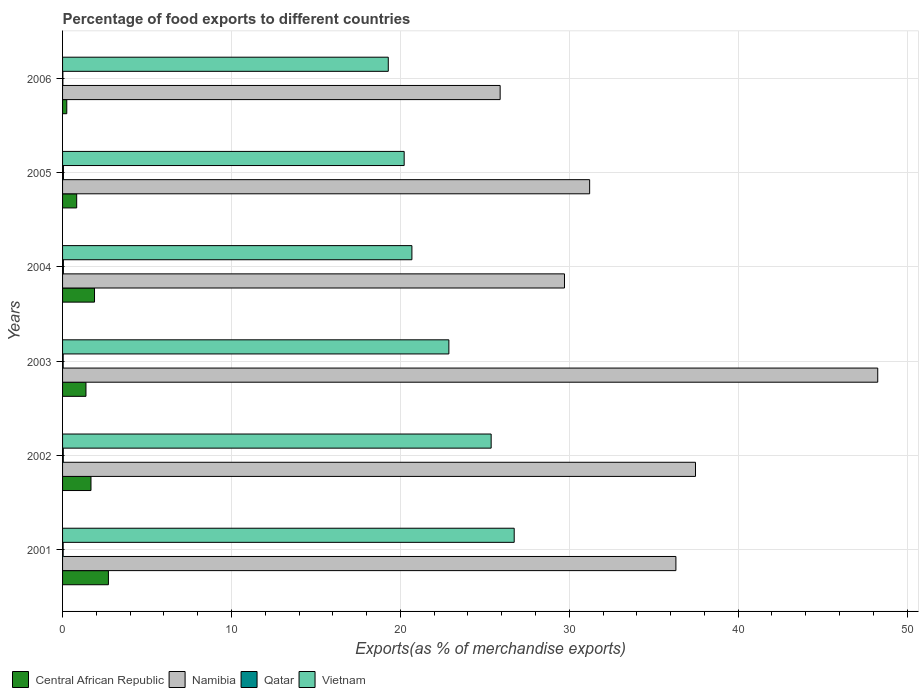How many groups of bars are there?
Offer a terse response. 6. Are the number of bars on each tick of the Y-axis equal?
Offer a terse response. Yes. What is the percentage of exports to different countries in Central African Republic in 2002?
Your answer should be very brief. 1.68. Across all years, what is the maximum percentage of exports to different countries in Qatar?
Your response must be concise. 0.05. Across all years, what is the minimum percentage of exports to different countries in Vietnam?
Ensure brevity in your answer.  19.29. In which year was the percentage of exports to different countries in Central African Republic maximum?
Your answer should be compact. 2001. What is the total percentage of exports to different countries in Namibia in the graph?
Ensure brevity in your answer.  208.9. What is the difference between the percentage of exports to different countries in Qatar in 2001 and that in 2003?
Ensure brevity in your answer.  -0. What is the difference between the percentage of exports to different countries in Central African Republic in 2004 and the percentage of exports to different countries in Qatar in 2002?
Your response must be concise. 1.85. What is the average percentage of exports to different countries in Namibia per year?
Keep it short and to the point. 34.82. In the year 2005, what is the difference between the percentage of exports to different countries in Qatar and percentage of exports to different countries in Namibia?
Provide a succinct answer. -31.16. In how many years, is the percentage of exports to different countries in Namibia greater than 24 %?
Offer a very short reply. 6. What is the ratio of the percentage of exports to different countries in Namibia in 2004 to that in 2005?
Ensure brevity in your answer.  0.95. Is the percentage of exports to different countries in Namibia in 2001 less than that in 2004?
Provide a short and direct response. No. What is the difference between the highest and the second highest percentage of exports to different countries in Namibia?
Your answer should be compact. 10.79. What is the difference between the highest and the lowest percentage of exports to different countries in Namibia?
Your response must be concise. 22.36. What does the 3rd bar from the top in 2001 represents?
Provide a succinct answer. Namibia. What does the 1st bar from the bottom in 2003 represents?
Offer a terse response. Central African Republic. Is it the case that in every year, the sum of the percentage of exports to different countries in Vietnam and percentage of exports to different countries in Namibia is greater than the percentage of exports to different countries in Qatar?
Keep it short and to the point. Yes. Are the values on the major ticks of X-axis written in scientific E-notation?
Provide a short and direct response. No. Does the graph contain any zero values?
Keep it short and to the point. No. Where does the legend appear in the graph?
Offer a terse response. Bottom left. What is the title of the graph?
Offer a terse response. Percentage of food exports to different countries. What is the label or title of the X-axis?
Offer a terse response. Exports(as % of merchandise exports). What is the Exports(as % of merchandise exports) of Central African Republic in 2001?
Your response must be concise. 2.71. What is the Exports(as % of merchandise exports) in Namibia in 2001?
Give a very brief answer. 36.32. What is the Exports(as % of merchandise exports) of Qatar in 2001?
Offer a terse response. 0.04. What is the Exports(as % of merchandise exports) in Vietnam in 2001?
Your response must be concise. 26.74. What is the Exports(as % of merchandise exports) in Central African Republic in 2002?
Give a very brief answer. 1.68. What is the Exports(as % of merchandise exports) in Namibia in 2002?
Offer a terse response. 37.48. What is the Exports(as % of merchandise exports) in Qatar in 2002?
Your answer should be compact. 0.04. What is the Exports(as % of merchandise exports) in Vietnam in 2002?
Ensure brevity in your answer.  25.38. What is the Exports(as % of merchandise exports) in Central African Republic in 2003?
Ensure brevity in your answer.  1.39. What is the Exports(as % of merchandise exports) of Namibia in 2003?
Provide a short and direct response. 48.27. What is the Exports(as % of merchandise exports) of Qatar in 2003?
Your answer should be very brief. 0.04. What is the Exports(as % of merchandise exports) in Vietnam in 2003?
Ensure brevity in your answer.  22.87. What is the Exports(as % of merchandise exports) in Central African Republic in 2004?
Keep it short and to the point. 1.89. What is the Exports(as % of merchandise exports) of Namibia in 2004?
Make the answer very short. 29.72. What is the Exports(as % of merchandise exports) of Qatar in 2004?
Provide a succinct answer. 0.05. What is the Exports(as % of merchandise exports) of Vietnam in 2004?
Provide a short and direct response. 20.69. What is the Exports(as % of merchandise exports) in Central African Republic in 2005?
Offer a terse response. 0.84. What is the Exports(as % of merchandise exports) in Namibia in 2005?
Make the answer very short. 31.21. What is the Exports(as % of merchandise exports) of Qatar in 2005?
Your answer should be very brief. 0.05. What is the Exports(as % of merchandise exports) of Vietnam in 2005?
Give a very brief answer. 20.23. What is the Exports(as % of merchandise exports) in Central African Republic in 2006?
Offer a very short reply. 0.25. What is the Exports(as % of merchandise exports) of Namibia in 2006?
Keep it short and to the point. 25.91. What is the Exports(as % of merchandise exports) of Qatar in 2006?
Keep it short and to the point. 0.02. What is the Exports(as % of merchandise exports) in Vietnam in 2006?
Offer a terse response. 19.29. Across all years, what is the maximum Exports(as % of merchandise exports) in Central African Republic?
Your answer should be compact. 2.71. Across all years, what is the maximum Exports(as % of merchandise exports) of Namibia?
Offer a terse response. 48.27. Across all years, what is the maximum Exports(as % of merchandise exports) in Qatar?
Give a very brief answer. 0.05. Across all years, what is the maximum Exports(as % of merchandise exports) in Vietnam?
Provide a short and direct response. 26.74. Across all years, what is the minimum Exports(as % of merchandise exports) of Central African Republic?
Provide a short and direct response. 0.25. Across all years, what is the minimum Exports(as % of merchandise exports) in Namibia?
Give a very brief answer. 25.91. Across all years, what is the minimum Exports(as % of merchandise exports) in Qatar?
Give a very brief answer. 0.02. Across all years, what is the minimum Exports(as % of merchandise exports) in Vietnam?
Keep it short and to the point. 19.29. What is the total Exports(as % of merchandise exports) in Central African Republic in the graph?
Make the answer very short. 8.76. What is the total Exports(as % of merchandise exports) in Namibia in the graph?
Offer a very short reply. 208.9. What is the total Exports(as % of merchandise exports) in Qatar in the graph?
Offer a very short reply. 0.23. What is the total Exports(as % of merchandise exports) of Vietnam in the graph?
Ensure brevity in your answer.  135.19. What is the difference between the Exports(as % of merchandise exports) in Central African Republic in 2001 and that in 2002?
Ensure brevity in your answer.  1.03. What is the difference between the Exports(as % of merchandise exports) in Namibia in 2001 and that in 2002?
Offer a very short reply. -1.16. What is the difference between the Exports(as % of merchandise exports) of Qatar in 2001 and that in 2002?
Give a very brief answer. -0.01. What is the difference between the Exports(as % of merchandise exports) in Vietnam in 2001 and that in 2002?
Your answer should be compact. 1.36. What is the difference between the Exports(as % of merchandise exports) of Central African Republic in 2001 and that in 2003?
Offer a terse response. 1.33. What is the difference between the Exports(as % of merchandise exports) in Namibia in 2001 and that in 2003?
Ensure brevity in your answer.  -11.95. What is the difference between the Exports(as % of merchandise exports) of Qatar in 2001 and that in 2003?
Make the answer very short. -0. What is the difference between the Exports(as % of merchandise exports) of Vietnam in 2001 and that in 2003?
Ensure brevity in your answer.  3.87. What is the difference between the Exports(as % of merchandise exports) of Central African Republic in 2001 and that in 2004?
Offer a terse response. 0.82. What is the difference between the Exports(as % of merchandise exports) in Namibia in 2001 and that in 2004?
Your answer should be very brief. 6.6. What is the difference between the Exports(as % of merchandise exports) in Qatar in 2001 and that in 2004?
Keep it short and to the point. -0.01. What is the difference between the Exports(as % of merchandise exports) in Vietnam in 2001 and that in 2004?
Your answer should be very brief. 6.06. What is the difference between the Exports(as % of merchandise exports) of Central African Republic in 2001 and that in 2005?
Provide a short and direct response. 1.88. What is the difference between the Exports(as % of merchandise exports) of Namibia in 2001 and that in 2005?
Your answer should be compact. 5.11. What is the difference between the Exports(as % of merchandise exports) in Qatar in 2001 and that in 2005?
Make the answer very short. -0.02. What is the difference between the Exports(as % of merchandise exports) of Vietnam in 2001 and that in 2005?
Give a very brief answer. 6.51. What is the difference between the Exports(as % of merchandise exports) in Central African Republic in 2001 and that in 2006?
Your answer should be compact. 2.46. What is the difference between the Exports(as % of merchandise exports) of Namibia in 2001 and that in 2006?
Keep it short and to the point. 10.41. What is the difference between the Exports(as % of merchandise exports) in Qatar in 2001 and that in 2006?
Offer a very short reply. 0.02. What is the difference between the Exports(as % of merchandise exports) of Vietnam in 2001 and that in 2006?
Your response must be concise. 7.46. What is the difference between the Exports(as % of merchandise exports) in Central African Republic in 2002 and that in 2003?
Make the answer very short. 0.3. What is the difference between the Exports(as % of merchandise exports) in Namibia in 2002 and that in 2003?
Your response must be concise. -10.79. What is the difference between the Exports(as % of merchandise exports) in Qatar in 2002 and that in 2003?
Give a very brief answer. 0.01. What is the difference between the Exports(as % of merchandise exports) in Vietnam in 2002 and that in 2003?
Make the answer very short. 2.5. What is the difference between the Exports(as % of merchandise exports) of Central African Republic in 2002 and that in 2004?
Keep it short and to the point. -0.21. What is the difference between the Exports(as % of merchandise exports) of Namibia in 2002 and that in 2004?
Your answer should be compact. 7.76. What is the difference between the Exports(as % of merchandise exports) of Qatar in 2002 and that in 2004?
Make the answer very short. -0.01. What is the difference between the Exports(as % of merchandise exports) in Vietnam in 2002 and that in 2004?
Offer a very short reply. 4.69. What is the difference between the Exports(as % of merchandise exports) in Central African Republic in 2002 and that in 2005?
Keep it short and to the point. 0.85. What is the difference between the Exports(as % of merchandise exports) in Namibia in 2002 and that in 2005?
Ensure brevity in your answer.  6.27. What is the difference between the Exports(as % of merchandise exports) of Qatar in 2002 and that in 2005?
Ensure brevity in your answer.  -0.01. What is the difference between the Exports(as % of merchandise exports) of Vietnam in 2002 and that in 2005?
Provide a short and direct response. 5.15. What is the difference between the Exports(as % of merchandise exports) in Central African Republic in 2002 and that in 2006?
Your answer should be compact. 1.43. What is the difference between the Exports(as % of merchandise exports) of Namibia in 2002 and that in 2006?
Your response must be concise. 11.57. What is the difference between the Exports(as % of merchandise exports) in Qatar in 2002 and that in 2006?
Offer a terse response. 0.02. What is the difference between the Exports(as % of merchandise exports) in Vietnam in 2002 and that in 2006?
Ensure brevity in your answer.  6.09. What is the difference between the Exports(as % of merchandise exports) in Central African Republic in 2003 and that in 2004?
Your answer should be very brief. -0.51. What is the difference between the Exports(as % of merchandise exports) in Namibia in 2003 and that in 2004?
Provide a short and direct response. 18.55. What is the difference between the Exports(as % of merchandise exports) in Qatar in 2003 and that in 2004?
Ensure brevity in your answer.  -0.01. What is the difference between the Exports(as % of merchandise exports) in Vietnam in 2003 and that in 2004?
Your answer should be compact. 2.19. What is the difference between the Exports(as % of merchandise exports) of Central African Republic in 2003 and that in 2005?
Offer a terse response. 0.55. What is the difference between the Exports(as % of merchandise exports) of Namibia in 2003 and that in 2005?
Provide a succinct answer. 17.06. What is the difference between the Exports(as % of merchandise exports) of Qatar in 2003 and that in 2005?
Your answer should be compact. -0.02. What is the difference between the Exports(as % of merchandise exports) of Vietnam in 2003 and that in 2005?
Keep it short and to the point. 2.65. What is the difference between the Exports(as % of merchandise exports) of Central African Republic in 2003 and that in 2006?
Offer a very short reply. 1.14. What is the difference between the Exports(as % of merchandise exports) of Namibia in 2003 and that in 2006?
Ensure brevity in your answer.  22.36. What is the difference between the Exports(as % of merchandise exports) in Qatar in 2003 and that in 2006?
Offer a terse response. 0.02. What is the difference between the Exports(as % of merchandise exports) in Vietnam in 2003 and that in 2006?
Provide a succinct answer. 3.59. What is the difference between the Exports(as % of merchandise exports) in Central African Republic in 2004 and that in 2005?
Ensure brevity in your answer.  1.06. What is the difference between the Exports(as % of merchandise exports) of Namibia in 2004 and that in 2005?
Your answer should be very brief. -1.49. What is the difference between the Exports(as % of merchandise exports) of Qatar in 2004 and that in 2005?
Offer a terse response. -0. What is the difference between the Exports(as % of merchandise exports) in Vietnam in 2004 and that in 2005?
Provide a succinct answer. 0.46. What is the difference between the Exports(as % of merchandise exports) in Central African Republic in 2004 and that in 2006?
Your response must be concise. 1.64. What is the difference between the Exports(as % of merchandise exports) of Namibia in 2004 and that in 2006?
Your response must be concise. 3.81. What is the difference between the Exports(as % of merchandise exports) in Qatar in 2004 and that in 2006?
Offer a very short reply. 0.03. What is the difference between the Exports(as % of merchandise exports) in Vietnam in 2004 and that in 2006?
Provide a succinct answer. 1.4. What is the difference between the Exports(as % of merchandise exports) of Central African Republic in 2005 and that in 2006?
Offer a very short reply. 0.59. What is the difference between the Exports(as % of merchandise exports) of Namibia in 2005 and that in 2006?
Offer a very short reply. 5.3. What is the difference between the Exports(as % of merchandise exports) of Qatar in 2005 and that in 2006?
Provide a short and direct response. 0.03. What is the difference between the Exports(as % of merchandise exports) of Vietnam in 2005 and that in 2006?
Ensure brevity in your answer.  0.94. What is the difference between the Exports(as % of merchandise exports) of Central African Republic in 2001 and the Exports(as % of merchandise exports) of Namibia in 2002?
Your answer should be very brief. -34.76. What is the difference between the Exports(as % of merchandise exports) in Central African Republic in 2001 and the Exports(as % of merchandise exports) in Qatar in 2002?
Offer a very short reply. 2.67. What is the difference between the Exports(as % of merchandise exports) in Central African Republic in 2001 and the Exports(as % of merchandise exports) in Vietnam in 2002?
Give a very brief answer. -22.66. What is the difference between the Exports(as % of merchandise exports) in Namibia in 2001 and the Exports(as % of merchandise exports) in Qatar in 2002?
Provide a short and direct response. 36.27. What is the difference between the Exports(as % of merchandise exports) of Namibia in 2001 and the Exports(as % of merchandise exports) of Vietnam in 2002?
Ensure brevity in your answer.  10.94. What is the difference between the Exports(as % of merchandise exports) of Qatar in 2001 and the Exports(as % of merchandise exports) of Vietnam in 2002?
Your response must be concise. -25.34. What is the difference between the Exports(as % of merchandise exports) of Central African Republic in 2001 and the Exports(as % of merchandise exports) of Namibia in 2003?
Offer a terse response. -45.55. What is the difference between the Exports(as % of merchandise exports) of Central African Republic in 2001 and the Exports(as % of merchandise exports) of Qatar in 2003?
Offer a very short reply. 2.68. What is the difference between the Exports(as % of merchandise exports) of Central African Republic in 2001 and the Exports(as % of merchandise exports) of Vietnam in 2003?
Offer a terse response. -20.16. What is the difference between the Exports(as % of merchandise exports) of Namibia in 2001 and the Exports(as % of merchandise exports) of Qatar in 2003?
Offer a very short reply. 36.28. What is the difference between the Exports(as % of merchandise exports) in Namibia in 2001 and the Exports(as % of merchandise exports) in Vietnam in 2003?
Keep it short and to the point. 13.44. What is the difference between the Exports(as % of merchandise exports) of Qatar in 2001 and the Exports(as % of merchandise exports) of Vietnam in 2003?
Provide a succinct answer. -22.84. What is the difference between the Exports(as % of merchandise exports) in Central African Republic in 2001 and the Exports(as % of merchandise exports) in Namibia in 2004?
Provide a succinct answer. -27. What is the difference between the Exports(as % of merchandise exports) of Central African Republic in 2001 and the Exports(as % of merchandise exports) of Qatar in 2004?
Provide a succinct answer. 2.67. What is the difference between the Exports(as % of merchandise exports) in Central African Republic in 2001 and the Exports(as % of merchandise exports) in Vietnam in 2004?
Your response must be concise. -17.97. What is the difference between the Exports(as % of merchandise exports) in Namibia in 2001 and the Exports(as % of merchandise exports) in Qatar in 2004?
Keep it short and to the point. 36.27. What is the difference between the Exports(as % of merchandise exports) of Namibia in 2001 and the Exports(as % of merchandise exports) of Vietnam in 2004?
Offer a terse response. 15.63. What is the difference between the Exports(as % of merchandise exports) of Qatar in 2001 and the Exports(as % of merchandise exports) of Vietnam in 2004?
Keep it short and to the point. -20.65. What is the difference between the Exports(as % of merchandise exports) in Central African Republic in 2001 and the Exports(as % of merchandise exports) in Namibia in 2005?
Your response must be concise. -28.49. What is the difference between the Exports(as % of merchandise exports) of Central African Republic in 2001 and the Exports(as % of merchandise exports) of Qatar in 2005?
Offer a very short reply. 2.66. What is the difference between the Exports(as % of merchandise exports) of Central African Republic in 2001 and the Exports(as % of merchandise exports) of Vietnam in 2005?
Ensure brevity in your answer.  -17.51. What is the difference between the Exports(as % of merchandise exports) of Namibia in 2001 and the Exports(as % of merchandise exports) of Qatar in 2005?
Your response must be concise. 36.26. What is the difference between the Exports(as % of merchandise exports) of Namibia in 2001 and the Exports(as % of merchandise exports) of Vietnam in 2005?
Make the answer very short. 16.09. What is the difference between the Exports(as % of merchandise exports) in Qatar in 2001 and the Exports(as % of merchandise exports) in Vietnam in 2005?
Offer a very short reply. -20.19. What is the difference between the Exports(as % of merchandise exports) of Central African Republic in 2001 and the Exports(as % of merchandise exports) of Namibia in 2006?
Make the answer very short. -23.19. What is the difference between the Exports(as % of merchandise exports) of Central African Republic in 2001 and the Exports(as % of merchandise exports) of Qatar in 2006?
Your response must be concise. 2.7. What is the difference between the Exports(as % of merchandise exports) of Central African Republic in 2001 and the Exports(as % of merchandise exports) of Vietnam in 2006?
Keep it short and to the point. -16.57. What is the difference between the Exports(as % of merchandise exports) of Namibia in 2001 and the Exports(as % of merchandise exports) of Qatar in 2006?
Provide a short and direct response. 36.3. What is the difference between the Exports(as % of merchandise exports) of Namibia in 2001 and the Exports(as % of merchandise exports) of Vietnam in 2006?
Provide a short and direct response. 17.03. What is the difference between the Exports(as % of merchandise exports) in Qatar in 2001 and the Exports(as % of merchandise exports) in Vietnam in 2006?
Keep it short and to the point. -19.25. What is the difference between the Exports(as % of merchandise exports) of Central African Republic in 2002 and the Exports(as % of merchandise exports) of Namibia in 2003?
Give a very brief answer. -46.58. What is the difference between the Exports(as % of merchandise exports) of Central African Republic in 2002 and the Exports(as % of merchandise exports) of Qatar in 2003?
Give a very brief answer. 1.65. What is the difference between the Exports(as % of merchandise exports) of Central African Republic in 2002 and the Exports(as % of merchandise exports) of Vietnam in 2003?
Provide a succinct answer. -21.19. What is the difference between the Exports(as % of merchandise exports) of Namibia in 2002 and the Exports(as % of merchandise exports) of Qatar in 2003?
Offer a terse response. 37.44. What is the difference between the Exports(as % of merchandise exports) of Namibia in 2002 and the Exports(as % of merchandise exports) of Vietnam in 2003?
Make the answer very short. 14.6. What is the difference between the Exports(as % of merchandise exports) of Qatar in 2002 and the Exports(as % of merchandise exports) of Vietnam in 2003?
Your answer should be very brief. -22.83. What is the difference between the Exports(as % of merchandise exports) of Central African Republic in 2002 and the Exports(as % of merchandise exports) of Namibia in 2004?
Your answer should be compact. -28.04. What is the difference between the Exports(as % of merchandise exports) of Central African Republic in 2002 and the Exports(as % of merchandise exports) of Qatar in 2004?
Your answer should be very brief. 1.63. What is the difference between the Exports(as % of merchandise exports) of Central African Republic in 2002 and the Exports(as % of merchandise exports) of Vietnam in 2004?
Your response must be concise. -19. What is the difference between the Exports(as % of merchandise exports) in Namibia in 2002 and the Exports(as % of merchandise exports) in Qatar in 2004?
Provide a succinct answer. 37.43. What is the difference between the Exports(as % of merchandise exports) in Namibia in 2002 and the Exports(as % of merchandise exports) in Vietnam in 2004?
Your answer should be very brief. 16.79. What is the difference between the Exports(as % of merchandise exports) in Qatar in 2002 and the Exports(as % of merchandise exports) in Vietnam in 2004?
Ensure brevity in your answer.  -20.64. What is the difference between the Exports(as % of merchandise exports) of Central African Republic in 2002 and the Exports(as % of merchandise exports) of Namibia in 2005?
Your response must be concise. -29.53. What is the difference between the Exports(as % of merchandise exports) in Central African Republic in 2002 and the Exports(as % of merchandise exports) in Qatar in 2005?
Provide a short and direct response. 1.63. What is the difference between the Exports(as % of merchandise exports) of Central African Republic in 2002 and the Exports(as % of merchandise exports) of Vietnam in 2005?
Provide a succinct answer. -18.54. What is the difference between the Exports(as % of merchandise exports) of Namibia in 2002 and the Exports(as % of merchandise exports) of Qatar in 2005?
Your response must be concise. 37.42. What is the difference between the Exports(as % of merchandise exports) of Namibia in 2002 and the Exports(as % of merchandise exports) of Vietnam in 2005?
Give a very brief answer. 17.25. What is the difference between the Exports(as % of merchandise exports) in Qatar in 2002 and the Exports(as % of merchandise exports) in Vietnam in 2005?
Offer a terse response. -20.19. What is the difference between the Exports(as % of merchandise exports) in Central African Republic in 2002 and the Exports(as % of merchandise exports) in Namibia in 2006?
Your response must be concise. -24.23. What is the difference between the Exports(as % of merchandise exports) in Central African Republic in 2002 and the Exports(as % of merchandise exports) in Qatar in 2006?
Your response must be concise. 1.66. What is the difference between the Exports(as % of merchandise exports) in Central African Republic in 2002 and the Exports(as % of merchandise exports) in Vietnam in 2006?
Your response must be concise. -17.6. What is the difference between the Exports(as % of merchandise exports) of Namibia in 2002 and the Exports(as % of merchandise exports) of Qatar in 2006?
Offer a terse response. 37.46. What is the difference between the Exports(as % of merchandise exports) in Namibia in 2002 and the Exports(as % of merchandise exports) in Vietnam in 2006?
Your response must be concise. 18.19. What is the difference between the Exports(as % of merchandise exports) of Qatar in 2002 and the Exports(as % of merchandise exports) of Vietnam in 2006?
Your response must be concise. -19.24. What is the difference between the Exports(as % of merchandise exports) in Central African Republic in 2003 and the Exports(as % of merchandise exports) in Namibia in 2004?
Give a very brief answer. -28.33. What is the difference between the Exports(as % of merchandise exports) in Central African Republic in 2003 and the Exports(as % of merchandise exports) in Qatar in 2004?
Keep it short and to the point. 1.34. What is the difference between the Exports(as % of merchandise exports) of Central African Republic in 2003 and the Exports(as % of merchandise exports) of Vietnam in 2004?
Offer a very short reply. -19.3. What is the difference between the Exports(as % of merchandise exports) in Namibia in 2003 and the Exports(as % of merchandise exports) in Qatar in 2004?
Give a very brief answer. 48.22. What is the difference between the Exports(as % of merchandise exports) in Namibia in 2003 and the Exports(as % of merchandise exports) in Vietnam in 2004?
Provide a succinct answer. 27.58. What is the difference between the Exports(as % of merchandise exports) of Qatar in 2003 and the Exports(as % of merchandise exports) of Vietnam in 2004?
Ensure brevity in your answer.  -20.65. What is the difference between the Exports(as % of merchandise exports) in Central African Republic in 2003 and the Exports(as % of merchandise exports) in Namibia in 2005?
Offer a very short reply. -29.82. What is the difference between the Exports(as % of merchandise exports) of Central African Republic in 2003 and the Exports(as % of merchandise exports) of Qatar in 2005?
Your response must be concise. 1.33. What is the difference between the Exports(as % of merchandise exports) of Central African Republic in 2003 and the Exports(as % of merchandise exports) of Vietnam in 2005?
Provide a short and direct response. -18.84. What is the difference between the Exports(as % of merchandise exports) in Namibia in 2003 and the Exports(as % of merchandise exports) in Qatar in 2005?
Your answer should be very brief. 48.21. What is the difference between the Exports(as % of merchandise exports) of Namibia in 2003 and the Exports(as % of merchandise exports) of Vietnam in 2005?
Give a very brief answer. 28.04. What is the difference between the Exports(as % of merchandise exports) in Qatar in 2003 and the Exports(as % of merchandise exports) in Vietnam in 2005?
Your answer should be very brief. -20.19. What is the difference between the Exports(as % of merchandise exports) of Central African Republic in 2003 and the Exports(as % of merchandise exports) of Namibia in 2006?
Ensure brevity in your answer.  -24.52. What is the difference between the Exports(as % of merchandise exports) in Central African Republic in 2003 and the Exports(as % of merchandise exports) in Qatar in 2006?
Give a very brief answer. 1.37. What is the difference between the Exports(as % of merchandise exports) of Central African Republic in 2003 and the Exports(as % of merchandise exports) of Vietnam in 2006?
Provide a short and direct response. -17.9. What is the difference between the Exports(as % of merchandise exports) in Namibia in 2003 and the Exports(as % of merchandise exports) in Qatar in 2006?
Offer a terse response. 48.25. What is the difference between the Exports(as % of merchandise exports) in Namibia in 2003 and the Exports(as % of merchandise exports) in Vietnam in 2006?
Your response must be concise. 28.98. What is the difference between the Exports(as % of merchandise exports) of Qatar in 2003 and the Exports(as % of merchandise exports) of Vietnam in 2006?
Provide a short and direct response. -19.25. What is the difference between the Exports(as % of merchandise exports) in Central African Republic in 2004 and the Exports(as % of merchandise exports) in Namibia in 2005?
Your response must be concise. -29.32. What is the difference between the Exports(as % of merchandise exports) of Central African Republic in 2004 and the Exports(as % of merchandise exports) of Qatar in 2005?
Keep it short and to the point. 1.84. What is the difference between the Exports(as % of merchandise exports) of Central African Republic in 2004 and the Exports(as % of merchandise exports) of Vietnam in 2005?
Keep it short and to the point. -18.34. What is the difference between the Exports(as % of merchandise exports) in Namibia in 2004 and the Exports(as % of merchandise exports) in Qatar in 2005?
Provide a short and direct response. 29.67. What is the difference between the Exports(as % of merchandise exports) in Namibia in 2004 and the Exports(as % of merchandise exports) in Vietnam in 2005?
Keep it short and to the point. 9.49. What is the difference between the Exports(as % of merchandise exports) in Qatar in 2004 and the Exports(as % of merchandise exports) in Vietnam in 2005?
Provide a succinct answer. -20.18. What is the difference between the Exports(as % of merchandise exports) in Central African Republic in 2004 and the Exports(as % of merchandise exports) in Namibia in 2006?
Your answer should be compact. -24.02. What is the difference between the Exports(as % of merchandise exports) of Central African Republic in 2004 and the Exports(as % of merchandise exports) of Qatar in 2006?
Your answer should be compact. 1.87. What is the difference between the Exports(as % of merchandise exports) of Central African Republic in 2004 and the Exports(as % of merchandise exports) of Vietnam in 2006?
Ensure brevity in your answer.  -17.39. What is the difference between the Exports(as % of merchandise exports) in Namibia in 2004 and the Exports(as % of merchandise exports) in Qatar in 2006?
Keep it short and to the point. 29.7. What is the difference between the Exports(as % of merchandise exports) in Namibia in 2004 and the Exports(as % of merchandise exports) in Vietnam in 2006?
Make the answer very short. 10.43. What is the difference between the Exports(as % of merchandise exports) in Qatar in 2004 and the Exports(as % of merchandise exports) in Vietnam in 2006?
Offer a terse response. -19.24. What is the difference between the Exports(as % of merchandise exports) of Central African Republic in 2005 and the Exports(as % of merchandise exports) of Namibia in 2006?
Your answer should be very brief. -25.07. What is the difference between the Exports(as % of merchandise exports) of Central African Republic in 2005 and the Exports(as % of merchandise exports) of Qatar in 2006?
Ensure brevity in your answer.  0.82. What is the difference between the Exports(as % of merchandise exports) in Central African Republic in 2005 and the Exports(as % of merchandise exports) in Vietnam in 2006?
Keep it short and to the point. -18.45. What is the difference between the Exports(as % of merchandise exports) in Namibia in 2005 and the Exports(as % of merchandise exports) in Qatar in 2006?
Your answer should be compact. 31.19. What is the difference between the Exports(as % of merchandise exports) of Namibia in 2005 and the Exports(as % of merchandise exports) of Vietnam in 2006?
Provide a short and direct response. 11.92. What is the difference between the Exports(as % of merchandise exports) in Qatar in 2005 and the Exports(as % of merchandise exports) in Vietnam in 2006?
Keep it short and to the point. -19.23. What is the average Exports(as % of merchandise exports) in Central African Republic per year?
Keep it short and to the point. 1.46. What is the average Exports(as % of merchandise exports) in Namibia per year?
Your answer should be very brief. 34.82. What is the average Exports(as % of merchandise exports) of Qatar per year?
Offer a very short reply. 0.04. What is the average Exports(as % of merchandise exports) of Vietnam per year?
Make the answer very short. 22.53. In the year 2001, what is the difference between the Exports(as % of merchandise exports) in Central African Republic and Exports(as % of merchandise exports) in Namibia?
Provide a short and direct response. -33.6. In the year 2001, what is the difference between the Exports(as % of merchandise exports) of Central African Republic and Exports(as % of merchandise exports) of Qatar?
Provide a succinct answer. 2.68. In the year 2001, what is the difference between the Exports(as % of merchandise exports) of Central African Republic and Exports(as % of merchandise exports) of Vietnam?
Your response must be concise. -24.03. In the year 2001, what is the difference between the Exports(as % of merchandise exports) in Namibia and Exports(as % of merchandise exports) in Qatar?
Make the answer very short. 36.28. In the year 2001, what is the difference between the Exports(as % of merchandise exports) of Namibia and Exports(as % of merchandise exports) of Vietnam?
Provide a succinct answer. 9.58. In the year 2001, what is the difference between the Exports(as % of merchandise exports) of Qatar and Exports(as % of merchandise exports) of Vietnam?
Your answer should be compact. -26.71. In the year 2002, what is the difference between the Exports(as % of merchandise exports) of Central African Republic and Exports(as % of merchandise exports) of Namibia?
Provide a short and direct response. -35.79. In the year 2002, what is the difference between the Exports(as % of merchandise exports) in Central African Republic and Exports(as % of merchandise exports) in Qatar?
Your answer should be very brief. 1.64. In the year 2002, what is the difference between the Exports(as % of merchandise exports) of Central African Republic and Exports(as % of merchandise exports) of Vietnam?
Offer a very short reply. -23.69. In the year 2002, what is the difference between the Exports(as % of merchandise exports) in Namibia and Exports(as % of merchandise exports) in Qatar?
Provide a short and direct response. 37.44. In the year 2002, what is the difference between the Exports(as % of merchandise exports) in Namibia and Exports(as % of merchandise exports) in Vietnam?
Provide a short and direct response. 12.1. In the year 2002, what is the difference between the Exports(as % of merchandise exports) in Qatar and Exports(as % of merchandise exports) in Vietnam?
Ensure brevity in your answer.  -25.34. In the year 2003, what is the difference between the Exports(as % of merchandise exports) of Central African Republic and Exports(as % of merchandise exports) of Namibia?
Your answer should be very brief. -46.88. In the year 2003, what is the difference between the Exports(as % of merchandise exports) of Central African Republic and Exports(as % of merchandise exports) of Qatar?
Offer a very short reply. 1.35. In the year 2003, what is the difference between the Exports(as % of merchandise exports) in Central African Republic and Exports(as % of merchandise exports) in Vietnam?
Your answer should be very brief. -21.49. In the year 2003, what is the difference between the Exports(as % of merchandise exports) of Namibia and Exports(as % of merchandise exports) of Qatar?
Your answer should be very brief. 48.23. In the year 2003, what is the difference between the Exports(as % of merchandise exports) of Namibia and Exports(as % of merchandise exports) of Vietnam?
Provide a short and direct response. 25.39. In the year 2003, what is the difference between the Exports(as % of merchandise exports) in Qatar and Exports(as % of merchandise exports) in Vietnam?
Provide a short and direct response. -22.84. In the year 2004, what is the difference between the Exports(as % of merchandise exports) of Central African Republic and Exports(as % of merchandise exports) of Namibia?
Ensure brevity in your answer.  -27.83. In the year 2004, what is the difference between the Exports(as % of merchandise exports) in Central African Republic and Exports(as % of merchandise exports) in Qatar?
Offer a terse response. 1.84. In the year 2004, what is the difference between the Exports(as % of merchandise exports) in Central African Republic and Exports(as % of merchandise exports) in Vietnam?
Keep it short and to the point. -18.79. In the year 2004, what is the difference between the Exports(as % of merchandise exports) in Namibia and Exports(as % of merchandise exports) in Qatar?
Keep it short and to the point. 29.67. In the year 2004, what is the difference between the Exports(as % of merchandise exports) in Namibia and Exports(as % of merchandise exports) in Vietnam?
Provide a succinct answer. 9.03. In the year 2004, what is the difference between the Exports(as % of merchandise exports) in Qatar and Exports(as % of merchandise exports) in Vietnam?
Your response must be concise. -20.64. In the year 2005, what is the difference between the Exports(as % of merchandise exports) of Central African Republic and Exports(as % of merchandise exports) of Namibia?
Your answer should be very brief. -30.37. In the year 2005, what is the difference between the Exports(as % of merchandise exports) in Central African Republic and Exports(as % of merchandise exports) in Qatar?
Provide a succinct answer. 0.78. In the year 2005, what is the difference between the Exports(as % of merchandise exports) in Central African Republic and Exports(as % of merchandise exports) in Vietnam?
Give a very brief answer. -19.39. In the year 2005, what is the difference between the Exports(as % of merchandise exports) in Namibia and Exports(as % of merchandise exports) in Qatar?
Ensure brevity in your answer.  31.16. In the year 2005, what is the difference between the Exports(as % of merchandise exports) in Namibia and Exports(as % of merchandise exports) in Vietnam?
Your response must be concise. 10.98. In the year 2005, what is the difference between the Exports(as % of merchandise exports) in Qatar and Exports(as % of merchandise exports) in Vietnam?
Your answer should be very brief. -20.17. In the year 2006, what is the difference between the Exports(as % of merchandise exports) in Central African Republic and Exports(as % of merchandise exports) in Namibia?
Your answer should be compact. -25.66. In the year 2006, what is the difference between the Exports(as % of merchandise exports) in Central African Republic and Exports(as % of merchandise exports) in Qatar?
Your answer should be very brief. 0.23. In the year 2006, what is the difference between the Exports(as % of merchandise exports) in Central African Republic and Exports(as % of merchandise exports) in Vietnam?
Provide a short and direct response. -19.04. In the year 2006, what is the difference between the Exports(as % of merchandise exports) in Namibia and Exports(as % of merchandise exports) in Qatar?
Ensure brevity in your answer.  25.89. In the year 2006, what is the difference between the Exports(as % of merchandise exports) of Namibia and Exports(as % of merchandise exports) of Vietnam?
Provide a short and direct response. 6.62. In the year 2006, what is the difference between the Exports(as % of merchandise exports) of Qatar and Exports(as % of merchandise exports) of Vietnam?
Your response must be concise. -19.27. What is the ratio of the Exports(as % of merchandise exports) in Central African Republic in 2001 to that in 2002?
Provide a succinct answer. 1.61. What is the ratio of the Exports(as % of merchandise exports) in Qatar in 2001 to that in 2002?
Offer a terse response. 0.84. What is the ratio of the Exports(as % of merchandise exports) of Vietnam in 2001 to that in 2002?
Your answer should be compact. 1.05. What is the ratio of the Exports(as % of merchandise exports) in Central African Republic in 2001 to that in 2003?
Provide a succinct answer. 1.96. What is the ratio of the Exports(as % of merchandise exports) of Namibia in 2001 to that in 2003?
Ensure brevity in your answer.  0.75. What is the ratio of the Exports(as % of merchandise exports) in Qatar in 2001 to that in 2003?
Make the answer very short. 0.99. What is the ratio of the Exports(as % of merchandise exports) of Vietnam in 2001 to that in 2003?
Ensure brevity in your answer.  1.17. What is the ratio of the Exports(as % of merchandise exports) of Central African Republic in 2001 to that in 2004?
Keep it short and to the point. 1.44. What is the ratio of the Exports(as % of merchandise exports) in Namibia in 2001 to that in 2004?
Your response must be concise. 1.22. What is the ratio of the Exports(as % of merchandise exports) in Qatar in 2001 to that in 2004?
Make the answer very short. 0.71. What is the ratio of the Exports(as % of merchandise exports) of Vietnam in 2001 to that in 2004?
Your response must be concise. 1.29. What is the ratio of the Exports(as % of merchandise exports) of Central African Republic in 2001 to that in 2005?
Provide a short and direct response. 3.25. What is the ratio of the Exports(as % of merchandise exports) in Namibia in 2001 to that in 2005?
Provide a succinct answer. 1.16. What is the ratio of the Exports(as % of merchandise exports) of Qatar in 2001 to that in 2005?
Keep it short and to the point. 0.67. What is the ratio of the Exports(as % of merchandise exports) in Vietnam in 2001 to that in 2005?
Your answer should be compact. 1.32. What is the ratio of the Exports(as % of merchandise exports) in Central African Republic in 2001 to that in 2006?
Offer a terse response. 10.86. What is the ratio of the Exports(as % of merchandise exports) in Namibia in 2001 to that in 2006?
Keep it short and to the point. 1.4. What is the ratio of the Exports(as % of merchandise exports) in Qatar in 2001 to that in 2006?
Offer a very short reply. 1.85. What is the ratio of the Exports(as % of merchandise exports) of Vietnam in 2001 to that in 2006?
Provide a short and direct response. 1.39. What is the ratio of the Exports(as % of merchandise exports) in Central African Republic in 2002 to that in 2003?
Keep it short and to the point. 1.21. What is the ratio of the Exports(as % of merchandise exports) of Namibia in 2002 to that in 2003?
Your response must be concise. 0.78. What is the ratio of the Exports(as % of merchandise exports) in Qatar in 2002 to that in 2003?
Your answer should be compact. 1.18. What is the ratio of the Exports(as % of merchandise exports) of Vietnam in 2002 to that in 2003?
Your response must be concise. 1.11. What is the ratio of the Exports(as % of merchandise exports) in Central African Republic in 2002 to that in 2004?
Your response must be concise. 0.89. What is the ratio of the Exports(as % of merchandise exports) in Namibia in 2002 to that in 2004?
Make the answer very short. 1.26. What is the ratio of the Exports(as % of merchandise exports) in Qatar in 2002 to that in 2004?
Keep it short and to the point. 0.85. What is the ratio of the Exports(as % of merchandise exports) of Vietnam in 2002 to that in 2004?
Offer a terse response. 1.23. What is the ratio of the Exports(as % of merchandise exports) in Central African Republic in 2002 to that in 2005?
Offer a very short reply. 2.01. What is the ratio of the Exports(as % of merchandise exports) of Namibia in 2002 to that in 2005?
Ensure brevity in your answer.  1.2. What is the ratio of the Exports(as % of merchandise exports) in Qatar in 2002 to that in 2005?
Provide a succinct answer. 0.8. What is the ratio of the Exports(as % of merchandise exports) of Vietnam in 2002 to that in 2005?
Ensure brevity in your answer.  1.25. What is the ratio of the Exports(as % of merchandise exports) of Central African Republic in 2002 to that in 2006?
Offer a very short reply. 6.73. What is the ratio of the Exports(as % of merchandise exports) of Namibia in 2002 to that in 2006?
Provide a short and direct response. 1.45. What is the ratio of the Exports(as % of merchandise exports) in Qatar in 2002 to that in 2006?
Offer a very short reply. 2.21. What is the ratio of the Exports(as % of merchandise exports) in Vietnam in 2002 to that in 2006?
Ensure brevity in your answer.  1.32. What is the ratio of the Exports(as % of merchandise exports) of Central African Republic in 2003 to that in 2004?
Your answer should be compact. 0.73. What is the ratio of the Exports(as % of merchandise exports) of Namibia in 2003 to that in 2004?
Your response must be concise. 1.62. What is the ratio of the Exports(as % of merchandise exports) in Qatar in 2003 to that in 2004?
Offer a terse response. 0.72. What is the ratio of the Exports(as % of merchandise exports) in Vietnam in 2003 to that in 2004?
Offer a very short reply. 1.11. What is the ratio of the Exports(as % of merchandise exports) of Central African Republic in 2003 to that in 2005?
Your answer should be compact. 1.66. What is the ratio of the Exports(as % of merchandise exports) in Namibia in 2003 to that in 2005?
Offer a terse response. 1.55. What is the ratio of the Exports(as % of merchandise exports) in Qatar in 2003 to that in 2005?
Make the answer very short. 0.68. What is the ratio of the Exports(as % of merchandise exports) of Vietnam in 2003 to that in 2005?
Ensure brevity in your answer.  1.13. What is the ratio of the Exports(as % of merchandise exports) of Central African Republic in 2003 to that in 2006?
Keep it short and to the point. 5.54. What is the ratio of the Exports(as % of merchandise exports) of Namibia in 2003 to that in 2006?
Your answer should be compact. 1.86. What is the ratio of the Exports(as % of merchandise exports) in Qatar in 2003 to that in 2006?
Make the answer very short. 1.87. What is the ratio of the Exports(as % of merchandise exports) in Vietnam in 2003 to that in 2006?
Offer a terse response. 1.19. What is the ratio of the Exports(as % of merchandise exports) of Central African Republic in 2004 to that in 2005?
Your response must be concise. 2.26. What is the ratio of the Exports(as % of merchandise exports) of Namibia in 2004 to that in 2005?
Offer a terse response. 0.95. What is the ratio of the Exports(as % of merchandise exports) of Qatar in 2004 to that in 2005?
Keep it short and to the point. 0.94. What is the ratio of the Exports(as % of merchandise exports) in Vietnam in 2004 to that in 2005?
Your response must be concise. 1.02. What is the ratio of the Exports(as % of merchandise exports) in Central African Republic in 2004 to that in 2006?
Make the answer very short. 7.57. What is the ratio of the Exports(as % of merchandise exports) of Namibia in 2004 to that in 2006?
Keep it short and to the point. 1.15. What is the ratio of the Exports(as % of merchandise exports) in Qatar in 2004 to that in 2006?
Make the answer very short. 2.61. What is the ratio of the Exports(as % of merchandise exports) in Vietnam in 2004 to that in 2006?
Provide a short and direct response. 1.07. What is the ratio of the Exports(as % of merchandise exports) of Central African Republic in 2005 to that in 2006?
Provide a short and direct response. 3.34. What is the ratio of the Exports(as % of merchandise exports) of Namibia in 2005 to that in 2006?
Offer a terse response. 1.2. What is the ratio of the Exports(as % of merchandise exports) of Qatar in 2005 to that in 2006?
Ensure brevity in your answer.  2.77. What is the ratio of the Exports(as % of merchandise exports) of Vietnam in 2005 to that in 2006?
Keep it short and to the point. 1.05. What is the difference between the highest and the second highest Exports(as % of merchandise exports) of Central African Republic?
Make the answer very short. 0.82. What is the difference between the highest and the second highest Exports(as % of merchandise exports) in Namibia?
Provide a succinct answer. 10.79. What is the difference between the highest and the second highest Exports(as % of merchandise exports) of Qatar?
Offer a very short reply. 0. What is the difference between the highest and the second highest Exports(as % of merchandise exports) in Vietnam?
Ensure brevity in your answer.  1.36. What is the difference between the highest and the lowest Exports(as % of merchandise exports) of Central African Republic?
Provide a succinct answer. 2.46. What is the difference between the highest and the lowest Exports(as % of merchandise exports) of Namibia?
Your answer should be very brief. 22.36. What is the difference between the highest and the lowest Exports(as % of merchandise exports) of Qatar?
Your answer should be compact. 0.03. What is the difference between the highest and the lowest Exports(as % of merchandise exports) of Vietnam?
Offer a very short reply. 7.46. 